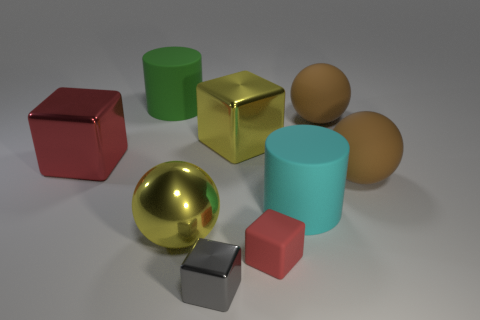Add 1 cylinders. How many objects exist? 10 Add 8 gray metal cubes. How many gray metal cubes are left? 9 Add 9 small yellow rubber cubes. How many small yellow rubber cubes exist? 9 Subtract all yellow balls. How many balls are left? 2 Subtract all large yellow blocks. How many blocks are left? 3 Subtract 1 green cylinders. How many objects are left? 8 Subtract all blocks. How many objects are left? 5 Subtract 2 spheres. How many spheres are left? 1 Subtract all cyan cylinders. Subtract all yellow blocks. How many cylinders are left? 1 Subtract all gray cylinders. How many red spheres are left? 0 